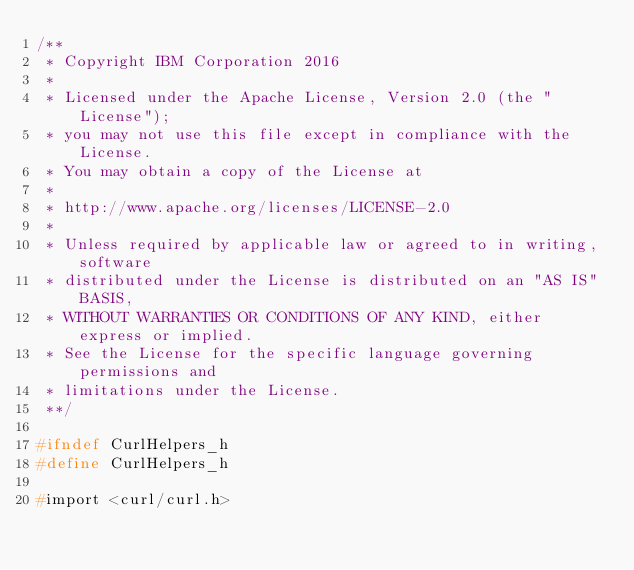Convert code to text. <code><loc_0><loc_0><loc_500><loc_500><_C_>/**
 * Copyright IBM Corporation 2016
 *
 * Licensed under the Apache License, Version 2.0 (the "License");
 * you may not use this file except in compliance with the License.
 * You may obtain a copy of the License at
 *
 * http://www.apache.org/licenses/LICENSE-2.0
 *
 * Unless required by applicable law or agreed to in writing, software
 * distributed under the License is distributed on an "AS IS" BASIS,
 * WITHOUT WARRANTIES OR CONDITIONS OF ANY KIND, either express or implied.
 * See the License for the specific language governing permissions and
 * limitations under the License.
 **/

#ifndef CurlHelpers_h
#define CurlHelpers_h

#import <curl/curl.h></code> 